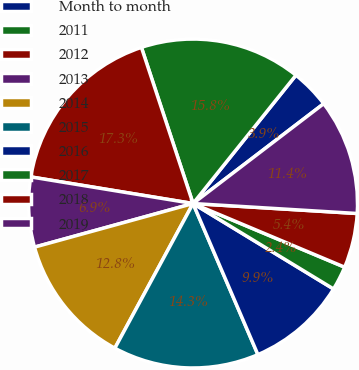<chart> <loc_0><loc_0><loc_500><loc_500><pie_chart><fcel>Month to month<fcel>2011<fcel>2012<fcel>2013<fcel>2014<fcel>2015<fcel>2016<fcel>2017<fcel>2018<fcel>2019<nl><fcel>3.86%<fcel>15.84%<fcel>17.33%<fcel>6.86%<fcel>12.84%<fcel>14.34%<fcel>9.85%<fcel>2.37%<fcel>5.36%<fcel>11.35%<nl></chart> 